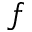Convert formula to latex. <formula><loc_0><loc_0><loc_500><loc_500>f</formula> 